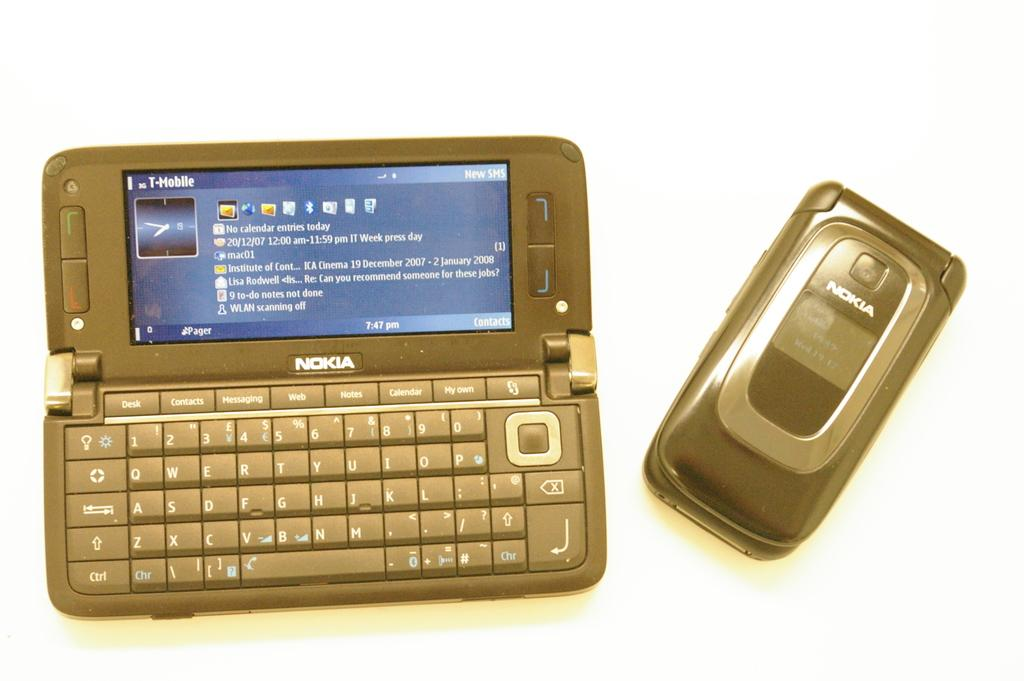<image>
Summarize the visual content of the image. Some Nokia electronics sit next to each other on a table. 